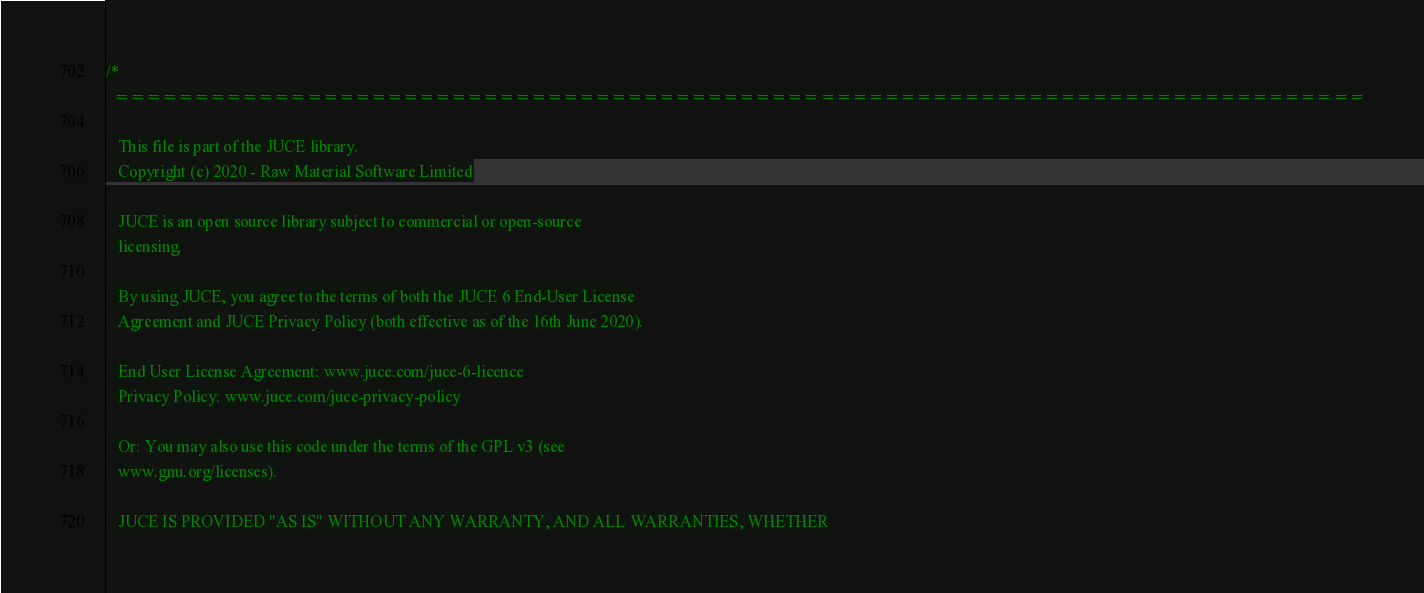Convert code to text. <code><loc_0><loc_0><loc_500><loc_500><_ObjectiveC_>/*
  ==============================================================================

   This file is part of the JUCE library.
   Copyright (c) 2020 - Raw Material Software Limited

   JUCE is an open source library subject to commercial or open-source
   licensing.

   By using JUCE, you agree to the terms of both the JUCE 6 End-User License
   Agreement and JUCE Privacy Policy (both effective as of the 16th June 2020).

   End User License Agreement: www.juce.com/juce-6-licence
   Privacy Policy: www.juce.com/juce-privacy-policy

   Or: You may also use this code under the terms of the GPL v3 (see
   www.gnu.org/licenses).

   JUCE IS PROVIDED "AS IS" WITHOUT ANY WARRANTY, AND ALL WARRANTIES, WHETHER</code> 